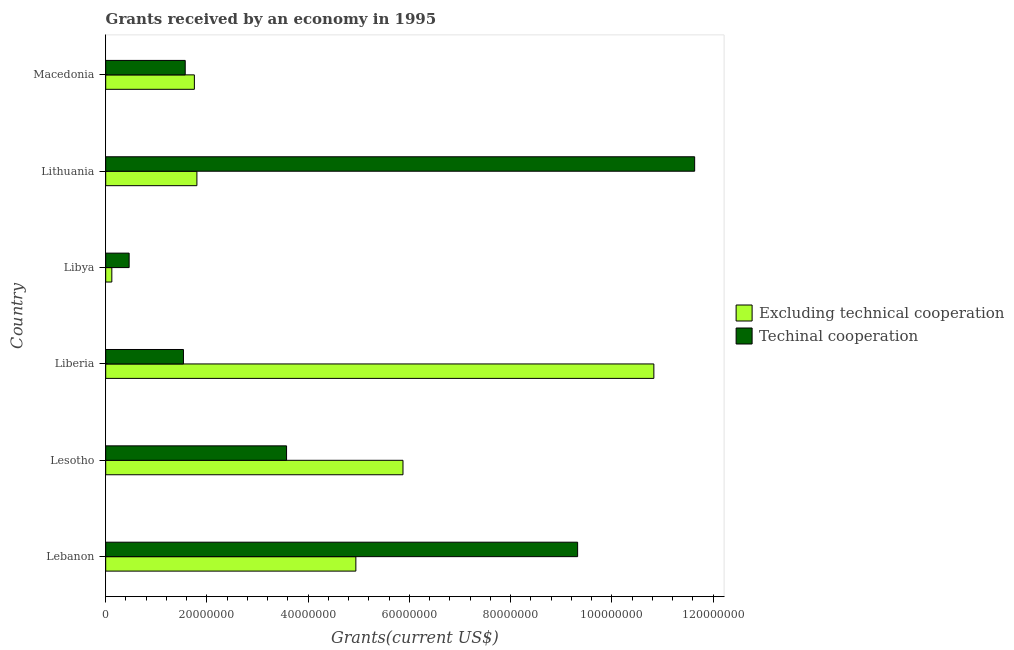How many groups of bars are there?
Make the answer very short. 6. Are the number of bars per tick equal to the number of legend labels?
Ensure brevity in your answer.  Yes. Are the number of bars on each tick of the Y-axis equal?
Provide a short and direct response. Yes. How many bars are there on the 6th tick from the bottom?
Provide a succinct answer. 2. What is the label of the 4th group of bars from the top?
Your answer should be very brief. Liberia. In how many cases, is the number of bars for a given country not equal to the number of legend labels?
Provide a short and direct response. 0. What is the amount of grants received(including technical cooperation) in Lithuania?
Give a very brief answer. 1.16e+08. Across all countries, what is the maximum amount of grants received(including technical cooperation)?
Give a very brief answer. 1.16e+08. Across all countries, what is the minimum amount of grants received(excluding technical cooperation)?
Your answer should be compact. 1.21e+06. In which country was the amount of grants received(excluding technical cooperation) maximum?
Make the answer very short. Liberia. In which country was the amount of grants received(including technical cooperation) minimum?
Give a very brief answer. Libya. What is the total amount of grants received(excluding technical cooperation) in the graph?
Your answer should be compact. 2.53e+08. What is the difference between the amount of grants received(including technical cooperation) in Libya and that in Lithuania?
Your response must be concise. -1.12e+08. What is the difference between the amount of grants received(including technical cooperation) in Lebanon and the amount of grants received(excluding technical cooperation) in Macedonia?
Provide a short and direct response. 7.57e+07. What is the average amount of grants received(excluding technical cooperation) per country?
Your answer should be very brief. 4.22e+07. What is the difference between the amount of grants received(excluding technical cooperation) and amount of grants received(including technical cooperation) in Lebanon?
Ensure brevity in your answer.  -4.38e+07. Is the amount of grants received(excluding technical cooperation) in Lesotho less than that in Liberia?
Your response must be concise. Yes. Is the difference between the amount of grants received(including technical cooperation) in Lesotho and Liberia greater than the difference between the amount of grants received(excluding technical cooperation) in Lesotho and Liberia?
Offer a terse response. Yes. What is the difference between the highest and the second highest amount of grants received(excluding technical cooperation)?
Your response must be concise. 4.96e+07. What is the difference between the highest and the lowest amount of grants received(excluding technical cooperation)?
Give a very brief answer. 1.07e+08. In how many countries, is the amount of grants received(including technical cooperation) greater than the average amount of grants received(including technical cooperation) taken over all countries?
Make the answer very short. 2. What does the 2nd bar from the top in Lithuania represents?
Offer a terse response. Excluding technical cooperation. What does the 2nd bar from the bottom in Lithuania represents?
Provide a short and direct response. Techinal cooperation. What is the difference between two consecutive major ticks on the X-axis?
Ensure brevity in your answer.  2.00e+07. Does the graph contain any zero values?
Keep it short and to the point. No. Does the graph contain grids?
Offer a very short reply. No. Where does the legend appear in the graph?
Provide a succinct answer. Center right. What is the title of the graph?
Your answer should be very brief. Grants received by an economy in 1995. Does "Quality of trade" appear as one of the legend labels in the graph?
Your response must be concise. No. What is the label or title of the X-axis?
Keep it short and to the point. Grants(current US$). What is the Grants(current US$) in Excluding technical cooperation in Lebanon?
Ensure brevity in your answer.  4.94e+07. What is the Grants(current US$) in Techinal cooperation in Lebanon?
Offer a terse response. 9.32e+07. What is the Grants(current US$) of Excluding technical cooperation in Lesotho?
Ensure brevity in your answer.  5.87e+07. What is the Grants(current US$) in Techinal cooperation in Lesotho?
Provide a short and direct response. 3.57e+07. What is the Grants(current US$) in Excluding technical cooperation in Liberia?
Provide a short and direct response. 1.08e+08. What is the Grants(current US$) of Techinal cooperation in Liberia?
Provide a succinct answer. 1.54e+07. What is the Grants(current US$) of Excluding technical cooperation in Libya?
Provide a short and direct response. 1.21e+06. What is the Grants(current US$) of Techinal cooperation in Libya?
Your answer should be very brief. 4.63e+06. What is the Grants(current US$) in Excluding technical cooperation in Lithuania?
Ensure brevity in your answer.  1.80e+07. What is the Grants(current US$) of Techinal cooperation in Lithuania?
Make the answer very short. 1.16e+08. What is the Grants(current US$) in Excluding technical cooperation in Macedonia?
Provide a short and direct response. 1.75e+07. What is the Grants(current US$) of Techinal cooperation in Macedonia?
Keep it short and to the point. 1.57e+07. Across all countries, what is the maximum Grants(current US$) in Excluding technical cooperation?
Your response must be concise. 1.08e+08. Across all countries, what is the maximum Grants(current US$) in Techinal cooperation?
Your answer should be compact. 1.16e+08. Across all countries, what is the minimum Grants(current US$) of Excluding technical cooperation?
Your answer should be compact. 1.21e+06. Across all countries, what is the minimum Grants(current US$) of Techinal cooperation?
Keep it short and to the point. 4.63e+06. What is the total Grants(current US$) of Excluding technical cooperation in the graph?
Your answer should be compact. 2.53e+08. What is the total Grants(current US$) in Techinal cooperation in the graph?
Offer a very short reply. 2.81e+08. What is the difference between the Grants(current US$) of Excluding technical cooperation in Lebanon and that in Lesotho?
Ensure brevity in your answer.  -9.31e+06. What is the difference between the Grants(current US$) in Techinal cooperation in Lebanon and that in Lesotho?
Your answer should be compact. 5.75e+07. What is the difference between the Grants(current US$) of Excluding technical cooperation in Lebanon and that in Liberia?
Offer a very short reply. -5.89e+07. What is the difference between the Grants(current US$) in Techinal cooperation in Lebanon and that in Liberia?
Ensure brevity in your answer.  7.79e+07. What is the difference between the Grants(current US$) of Excluding technical cooperation in Lebanon and that in Libya?
Make the answer very short. 4.82e+07. What is the difference between the Grants(current US$) in Techinal cooperation in Lebanon and that in Libya?
Make the answer very short. 8.86e+07. What is the difference between the Grants(current US$) in Excluding technical cooperation in Lebanon and that in Lithuania?
Offer a very short reply. 3.14e+07. What is the difference between the Grants(current US$) of Techinal cooperation in Lebanon and that in Lithuania?
Provide a short and direct response. -2.31e+07. What is the difference between the Grants(current US$) of Excluding technical cooperation in Lebanon and that in Macedonia?
Offer a terse response. 3.19e+07. What is the difference between the Grants(current US$) of Techinal cooperation in Lebanon and that in Macedonia?
Make the answer very short. 7.75e+07. What is the difference between the Grants(current US$) in Excluding technical cooperation in Lesotho and that in Liberia?
Give a very brief answer. -4.96e+07. What is the difference between the Grants(current US$) in Techinal cooperation in Lesotho and that in Liberia?
Your answer should be compact. 2.04e+07. What is the difference between the Grants(current US$) in Excluding technical cooperation in Lesotho and that in Libya?
Provide a short and direct response. 5.75e+07. What is the difference between the Grants(current US$) of Techinal cooperation in Lesotho and that in Libya?
Provide a short and direct response. 3.11e+07. What is the difference between the Grants(current US$) of Excluding technical cooperation in Lesotho and that in Lithuania?
Your answer should be compact. 4.07e+07. What is the difference between the Grants(current US$) of Techinal cooperation in Lesotho and that in Lithuania?
Make the answer very short. -8.06e+07. What is the difference between the Grants(current US$) in Excluding technical cooperation in Lesotho and that in Macedonia?
Your answer should be compact. 4.12e+07. What is the difference between the Grants(current US$) of Techinal cooperation in Lesotho and that in Macedonia?
Make the answer very short. 2.00e+07. What is the difference between the Grants(current US$) in Excluding technical cooperation in Liberia and that in Libya?
Keep it short and to the point. 1.07e+08. What is the difference between the Grants(current US$) of Techinal cooperation in Liberia and that in Libya?
Offer a very short reply. 1.07e+07. What is the difference between the Grants(current US$) in Excluding technical cooperation in Liberia and that in Lithuania?
Provide a succinct answer. 9.03e+07. What is the difference between the Grants(current US$) in Techinal cooperation in Liberia and that in Lithuania?
Ensure brevity in your answer.  -1.01e+08. What is the difference between the Grants(current US$) in Excluding technical cooperation in Liberia and that in Macedonia?
Provide a succinct answer. 9.08e+07. What is the difference between the Grants(current US$) of Techinal cooperation in Liberia and that in Macedonia?
Offer a very short reply. -3.50e+05. What is the difference between the Grants(current US$) in Excluding technical cooperation in Libya and that in Lithuania?
Offer a terse response. -1.68e+07. What is the difference between the Grants(current US$) of Techinal cooperation in Libya and that in Lithuania?
Your response must be concise. -1.12e+08. What is the difference between the Grants(current US$) of Excluding technical cooperation in Libya and that in Macedonia?
Ensure brevity in your answer.  -1.63e+07. What is the difference between the Grants(current US$) in Techinal cooperation in Libya and that in Macedonia?
Your response must be concise. -1.11e+07. What is the difference between the Grants(current US$) of Excluding technical cooperation in Lithuania and that in Macedonia?
Your response must be concise. 5.00e+05. What is the difference between the Grants(current US$) in Techinal cooperation in Lithuania and that in Macedonia?
Your answer should be very brief. 1.01e+08. What is the difference between the Grants(current US$) in Excluding technical cooperation in Lebanon and the Grants(current US$) in Techinal cooperation in Lesotho?
Keep it short and to the point. 1.37e+07. What is the difference between the Grants(current US$) in Excluding technical cooperation in Lebanon and the Grants(current US$) in Techinal cooperation in Liberia?
Your answer should be very brief. 3.41e+07. What is the difference between the Grants(current US$) in Excluding technical cooperation in Lebanon and the Grants(current US$) in Techinal cooperation in Libya?
Give a very brief answer. 4.48e+07. What is the difference between the Grants(current US$) in Excluding technical cooperation in Lebanon and the Grants(current US$) in Techinal cooperation in Lithuania?
Offer a very short reply. -6.69e+07. What is the difference between the Grants(current US$) of Excluding technical cooperation in Lebanon and the Grants(current US$) of Techinal cooperation in Macedonia?
Offer a terse response. 3.37e+07. What is the difference between the Grants(current US$) in Excluding technical cooperation in Lesotho and the Grants(current US$) in Techinal cooperation in Liberia?
Provide a short and direct response. 4.34e+07. What is the difference between the Grants(current US$) of Excluding technical cooperation in Lesotho and the Grants(current US$) of Techinal cooperation in Libya?
Ensure brevity in your answer.  5.41e+07. What is the difference between the Grants(current US$) of Excluding technical cooperation in Lesotho and the Grants(current US$) of Techinal cooperation in Lithuania?
Offer a very short reply. -5.76e+07. What is the difference between the Grants(current US$) in Excluding technical cooperation in Lesotho and the Grants(current US$) in Techinal cooperation in Macedonia?
Your answer should be compact. 4.30e+07. What is the difference between the Grants(current US$) of Excluding technical cooperation in Liberia and the Grants(current US$) of Techinal cooperation in Libya?
Give a very brief answer. 1.04e+08. What is the difference between the Grants(current US$) of Excluding technical cooperation in Liberia and the Grants(current US$) of Techinal cooperation in Lithuania?
Offer a very short reply. -8.06e+06. What is the difference between the Grants(current US$) of Excluding technical cooperation in Liberia and the Grants(current US$) of Techinal cooperation in Macedonia?
Provide a succinct answer. 9.26e+07. What is the difference between the Grants(current US$) of Excluding technical cooperation in Libya and the Grants(current US$) of Techinal cooperation in Lithuania?
Provide a succinct answer. -1.15e+08. What is the difference between the Grants(current US$) in Excluding technical cooperation in Libya and the Grants(current US$) in Techinal cooperation in Macedonia?
Keep it short and to the point. -1.45e+07. What is the difference between the Grants(current US$) in Excluding technical cooperation in Lithuania and the Grants(current US$) in Techinal cooperation in Macedonia?
Provide a short and direct response. 2.31e+06. What is the average Grants(current US$) of Excluding technical cooperation per country?
Your answer should be compact. 4.22e+07. What is the average Grants(current US$) of Techinal cooperation per country?
Your answer should be very brief. 4.68e+07. What is the difference between the Grants(current US$) of Excluding technical cooperation and Grants(current US$) of Techinal cooperation in Lebanon?
Keep it short and to the point. -4.38e+07. What is the difference between the Grants(current US$) in Excluding technical cooperation and Grants(current US$) in Techinal cooperation in Lesotho?
Give a very brief answer. 2.30e+07. What is the difference between the Grants(current US$) in Excluding technical cooperation and Grants(current US$) in Techinal cooperation in Liberia?
Your response must be concise. 9.29e+07. What is the difference between the Grants(current US$) in Excluding technical cooperation and Grants(current US$) in Techinal cooperation in Libya?
Provide a succinct answer. -3.42e+06. What is the difference between the Grants(current US$) of Excluding technical cooperation and Grants(current US$) of Techinal cooperation in Lithuania?
Your answer should be very brief. -9.83e+07. What is the difference between the Grants(current US$) of Excluding technical cooperation and Grants(current US$) of Techinal cooperation in Macedonia?
Ensure brevity in your answer.  1.81e+06. What is the ratio of the Grants(current US$) in Excluding technical cooperation in Lebanon to that in Lesotho?
Provide a succinct answer. 0.84. What is the ratio of the Grants(current US$) of Techinal cooperation in Lebanon to that in Lesotho?
Offer a terse response. 2.61. What is the ratio of the Grants(current US$) in Excluding technical cooperation in Lebanon to that in Liberia?
Give a very brief answer. 0.46. What is the ratio of the Grants(current US$) in Techinal cooperation in Lebanon to that in Liberia?
Your answer should be compact. 6.07. What is the ratio of the Grants(current US$) of Excluding technical cooperation in Lebanon to that in Libya?
Your answer should be very brief. 40.84. What is the ratio of the Grants(current US$) in Techinal cooperation in Lebanon to that in Libya?
Offer a terse response. 20.14. What is the ratio of the Grants(current US$) of Excluding technical cooperation in Lebanon to that in Lithuania?
Your answer should be compact. 2.74. What is the ratio of the Grants(current US$) in Techinal cooperation in Lebanon to that in Lithuania?
Provide a short and direct response. 0.8. What is the ratio of the Grants(current US$) in Excluding technical cooperation in Lebanon to that in Macedonia?
Offer a very short reply. 2.82. What is the ratio of the Grants(current US$) of Techinal cooperation in Lebanon to that in Macedonia?
Make the answer very short. 5.93. What is the ratio of the Grants(current US$) of Excluding technical cooperation in Lesotho to that in Liberia?
Your answer should be compact. 0.54. What is the ratio of the Grants(current US$) of Techinal cooperation in Lesotho to that in Liberia?
Your response must be concise. 2.33. What is the ratio of the Grants(current US$) of Excluding technical cooperation in Lesotho to that in Libya?
Your response must be concise. 48.54. What is the ratio of the Grants(current US$) in Techinal cooperation in Lesotho to that in Libya?
Offer a terse response. 7.72. What is the ratio of the Grants(current US$) in Excluding technical cooperation in Lesotho to that in Lithuania?
Your answer should be very brief. 3.26. What is the ratio of the Grants(current US$) in Techinal cooperation in Lesotho to that in Lithuania?
Offer a very short reply. 0.31. What is the ratio of the Grants(current US$) in Excluding technical cooperation in Lesotho to that in Macedonia?
Offer a terse response. 3.35. What is the ratio of the Grants(current US$) in Techinal cooperation in Lesotho to that in Macedonia?
Your answer should be compact. 2.27. What is the ratio of the Grants(current US$) of Excluding technical cooperation in Liberia to that in Libya?
Keep it short and to the point. 89.5. What is the ratio of the Grants(current US$) in Techinal cooperation in Liberia to that in Libya?
Keep it short and to the point. 3.32. What is the ratio of the Grants(current US$) of Excluding technical cooperation in Liberia to that in Lithuania?
Your response must be concise. 6.01. What is the ratio of the Grants(current US$) in Techinal cooperation in Liberia to that in Lithuania?
Keep it short and to the point. 0.13. What is the ratio of the Grants(current US$) in Excluding technical cooperation in Liberia to that in Macedonia?
Your answer should be very brief. 6.18. What is the ratio of the Grants(current US$) of Techinal cooperation in Liberia to that in Macedonia?
Your answer should be very brief. 0.98. What is the ratio of the Grants(current US$) in Excluding technical cooperation in Libya to that in Lithuania?
Offer a very short reply. 0.07. What is the ratio of the Grants(current US$) of Techinal cooperation in Libya to that in Lithuania?
Provide a short and direct response. 0.04. What is the ratio of the Grants(current US$) of Excluding technical cooperation in Libya to that in Macedonia?
Your answer should be very brief. 0.07. What is the ratio of the Grants(current US$) of Techinal cooperation in Libya to that in Macedonia?
Make the answer very short. 0.29. What is the ratio of the Grants(current US$) of Excluding technical cooperation in Lithuania to that in Macedonia?
Offer a terse response. 1.03. What is the ratio of the Grants(current US$) of Techinal cooperation in Lithuania to that in Macedonia?
Your answer should be very brief. 7.41. What is the difference between the highest and the second highest Grants(current US$) in Excluding technical cooperation?
Your answer should be very brief. 4.96e+07. What is the difference between the highest and the second highest Grants(current US$) in Techinal cooperation?
Your answer should be very brief. 2.31e+07. What is the difference between the highest and the lowest Grants(current US$) of Excluding technical cooperation?
Keep it short and to the point. 1.07e+08. What is the difference between the highest and the lowest Grants(current US$) of Techinal cooperation?
Provide a short and direct response. 1.12e+08. 